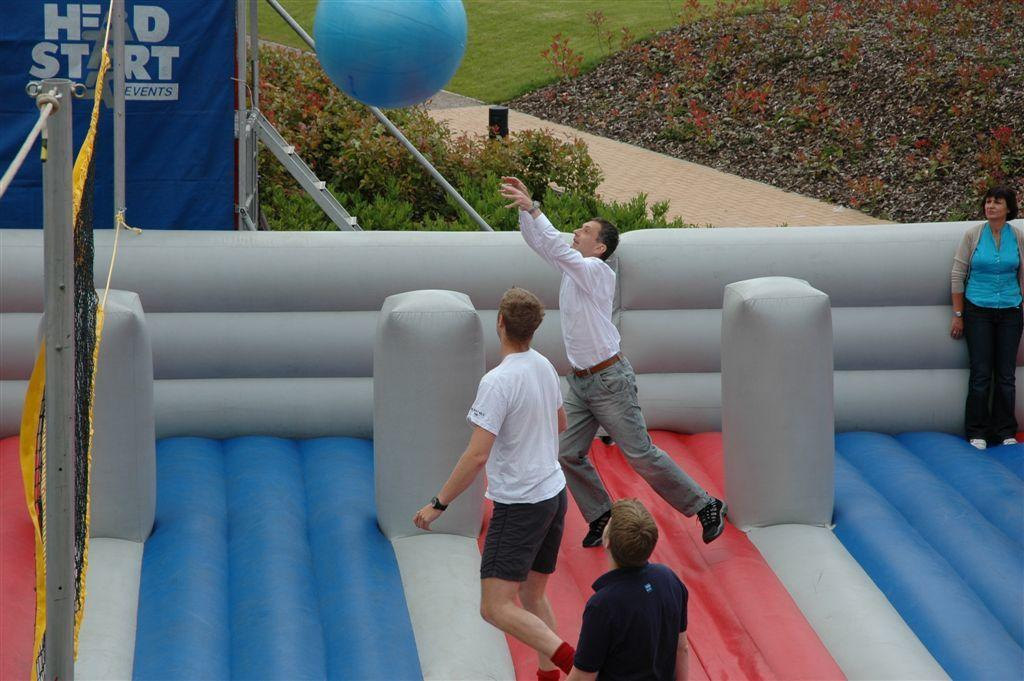What is the main object in the image? There is an inflatable in the image. What are the people inside the inflatable doing? A group of people are playing with a ball inside the inflatable. What type of natural environment is visible in the image? There are many trees and grass visible in the image. What type of spark can be seen coming from the trees in the image? There is no spark visible in the image; the trees are not on fire or emitting any sparks. 